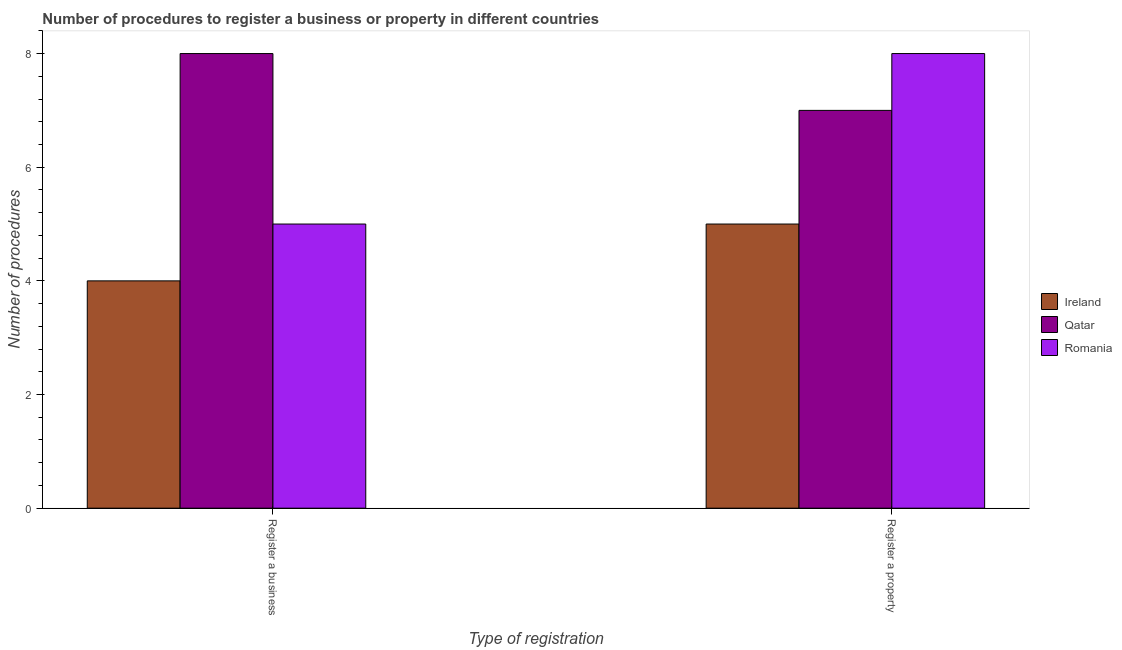How many bars are there on the 1st tick from the left?
Your answer should be very brief. 3. How many bars are there on the 2nd tick from the right?
Your answer should be compact. 3. What is the label of the 1st group of bars from the left?
Give a very brief answer. Register a business. What is the number of procedures to register a business in Ireland?
Provide a short and direct response. 4. Across all countries, what is the maximum number of procedures to register a business?
Your answer should be compact. 8. Across all countries, what is the minimum number of procedures to register a business?
Offer a terse response. 4. In which country was the number of procedures to register a business maximum?
Make the answer very short. Qatar. In which country was the number of procedures to register a business minimum?
Provide a short and direct response. Ireland. What is the total number of procedures to register a business in the graph?
Provide a succinct answer. 17. What is the difference between the number of procedures to register a property in Ireland and that in Romania?
Your answer should be very brief. -3. What is the difference between the number of procedures to register a business in Qatar and the number of procedures to register a property in Ireland?
Offer a terse response. 3. What is the average number of procedures to register a property per country?
Provide a succinct answer. 6.67. What is the difference between the number of procedures to register a property and number of procedures to register a business in Ireland?
Make the answer very short. 1. In how many countries, is the number of procedures to register a property greater than 1.6 ?
Your answer should be compact. 3. What does the 1st bar from the left in Register a business represents?
Your answer should be compact. Ireland. What does the 2nd bar from the right in Register a business represents?
Provide a short and direct response. Qatar. How many bars are there?
Offer a terse response. 6. What is the difference between two consecutive major ticks on the Y-axis?
Offer a very short reply. 2. Are the values on the major ticks of Y-axis written in scientific E-notation?
Make the answer very short. No. Does the graph contain any zero values?
Your answer should be very brief. No. Does the graph contain grids?
Keep it short and to the point. No. How many legend labels are there?
Ensure brevity in your answer.  3. How are the legend labels stacked?
Your answer should be compact. Vertical. What is the title of the graph?
Give a very brief answer. Number of procedures to register a business or property in different countries. Does "Congo (Democratic)" appear as one of the legend labels in the graph?
Offer a very short reply. No. What is the label or title of the X-axis?
Give a very brief answer. Type of registration. What is the label or title of the Y-axis?
Your response must be concise. Number of procedures. What is the Number of procedures of Ireland in Register a business?
Offer a very short reply. 4. Across all Type of registration, what is the minimum Number of procedures of Ireland?
Give a very brief answer. 4. Across all Type of registration, what is the minimum Number of procedures in Romania?
Ensure brevity in your answer.  5. What is the difference between the Number of procedures in Ireland in Register a business and that in Register a property?
Provide a short and direct response. -1. What is the difference between the Number of procedures of Ireland in Register a business and the Number of procedures of Qatar in Register a property?
Make the answer very short. -3. What is the difference between the Number of procedures in Ireland in Register a business and the Number of procedures in Romania in Register a property?
Give a very brief answer. -4. What is the average Number of procedures in Qatar per Type of registration?
Offer a terse response. 7.5. What is the difference between the Number of procedures in Ireland and Number of procedures in Qatar in Register a business?
Provide a succinct answer. -4. What is the difference between the Number of procedures of Ireland and Number of procedures of Romania in Register a business?
Keep it short and to the point. -1. What is the difference between the Number of procedures in Qatar and Number of procedures in Romania in Register a business?
Offer a very short reply. 3. What is the difference between the Number of procedures in Ireland and Number of procedures in Romania in Register a property?
Make the answer very short. -3. What is the ratio of the Number of procedures in Qatar in Register a business to that in Register a property?
Offer a terse response. 1.14. What is the ratio of the Number of procedures of Romania in Register a business to that in Register a property?
Provide a short and direct response. 0.62. What is the difference between the highest and the second highest Number of procedures of Romania?
Give a very brief answer. 3. What is the difference between the highest and the lowest Number of procedures of Qatar?
Your answer should be compact. 1. What is the difference between the highest and the lowest Number of procedures in Romania?
Give a very brief answer. 3. 